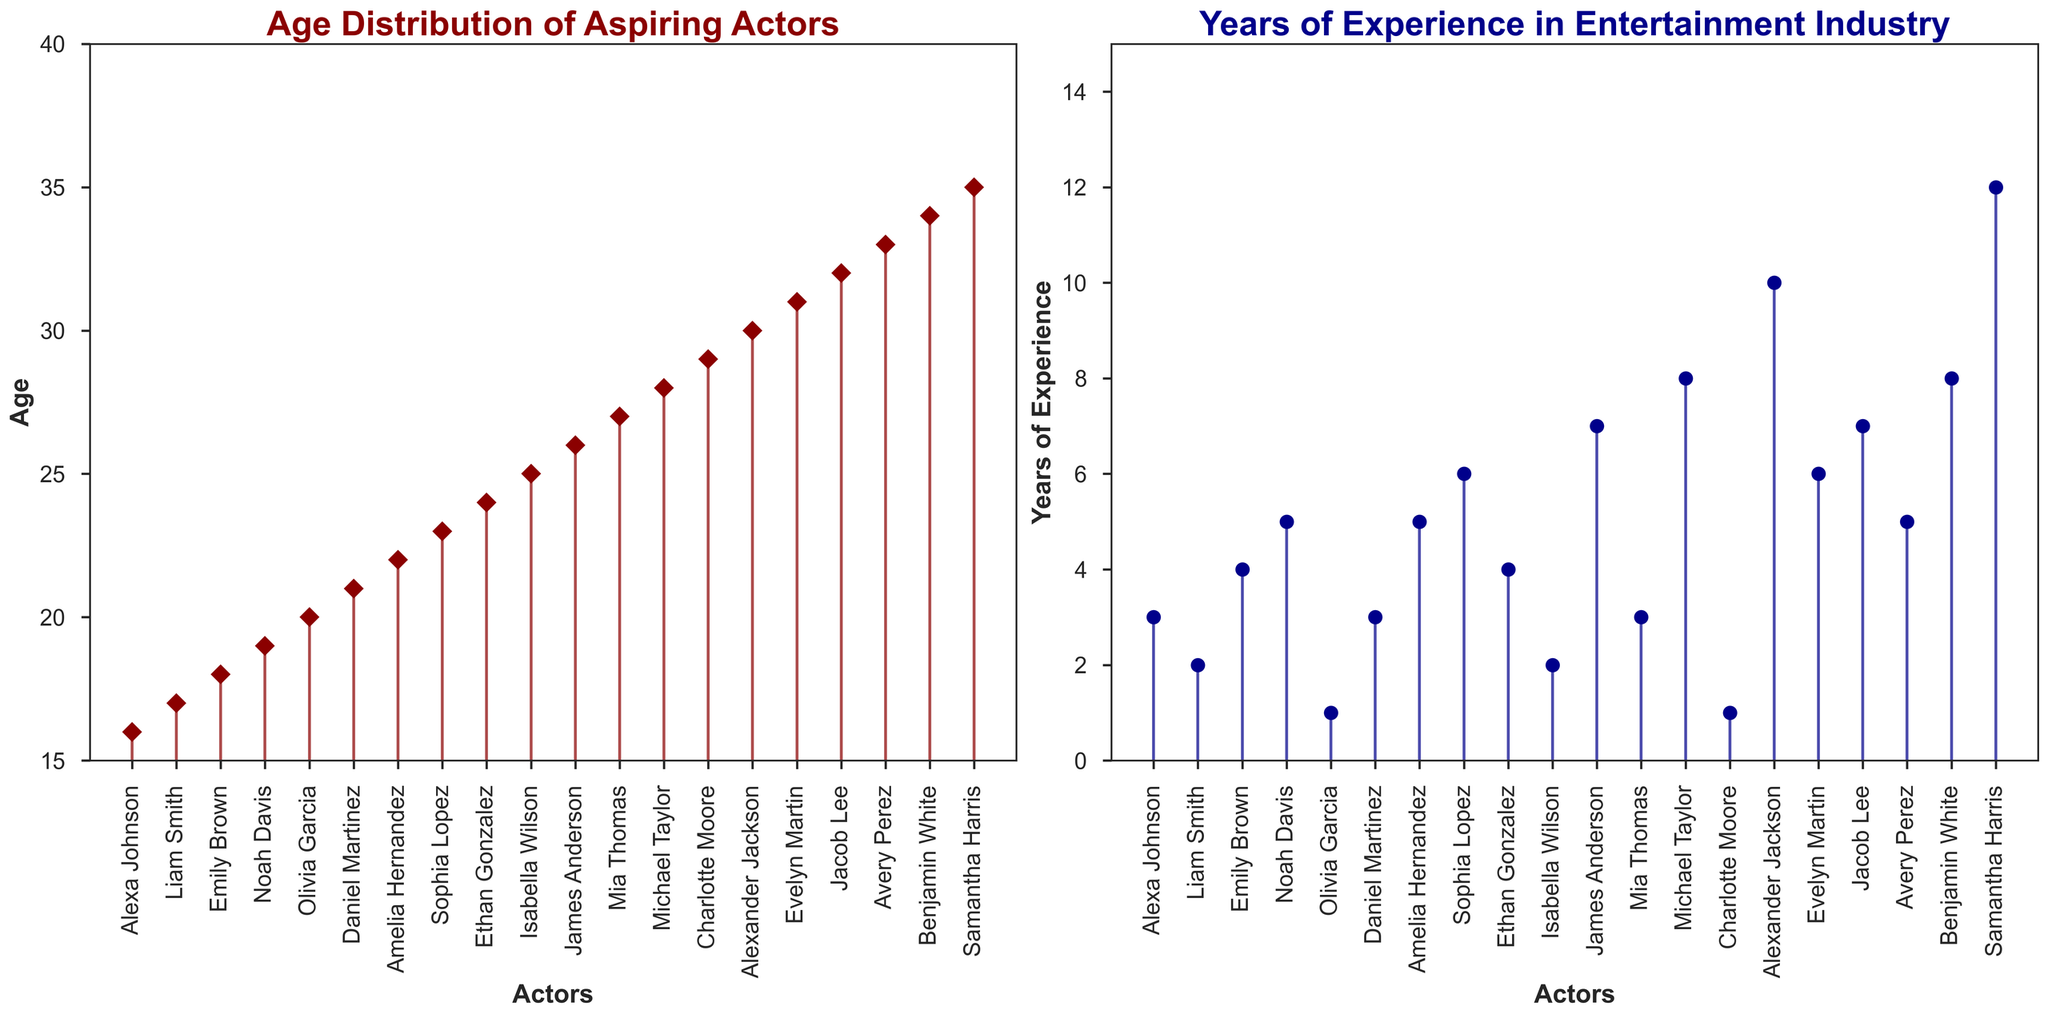Which axis shows the names of the actors in both subplots? The x-axis in both subplots lists the names of the actors. In the figure, the bottom axis shows each actor's name which is rotated 90 degrees for better readability.
Answer: x-axis What are the colors of the stem lines in each subplot? In the age distribution subplot on the left, the stem lines are dark red. In the years of experience subplot on the right, the stem lines are dark blue.
Answer: dark red, dark blue How many actors have their age listed in the age distribution subplot? By counting the names on the x-axis in the age distribution subplot, we can determine there are 20 actors.
Answer: 20 What is the range of ages represented in the age distribution subplot? The y-axis of the age distribution subplot shows the age range from 15 to 40. By examining the data points, the minimum age is 16 and the maximum age is 35.
Answer: 16, 35 Which actor has the highest number of years of experience? From the years of experience subplot, Samantha Harris, shown near the end of the x-axis, has the highest stem, indicating 12 years of experience.
Answer: Samantha Harris What is the average age of the aspiring actors? To find the average age, we sum all the ages and divide by the number of actors. The ages are 16, 17, 18, 19, 20, 21, 22, 23, 24, 25, 26, 27, 28, 29, 30, 31, 32, 33, 34, 35. The sum is 490. There are 20 actors, so the average age is 490 / 20.
Answer: 24.5 Are there any actors with the same age but different years of experience? By analyzing both subplots, it's clear that no two actors have the same age but different years of experience. Each age has a unique corresponding number of years of experience.
Answer: No Which actor is 30 years old and how many years of experience do they have? Based on the age distribution subplot, Alexander Jackson is 30 years old. Referring to the years of experience subplot, Alexander Jackson has 10 years of experience.
Answer: Alexander Jackson, 10 Who is the youngest actor and how many years of experience do they have? Alexa Johnson is the youngest actor, as indicated in the age distribution subplot. The years of experience subplot shows she has 3 years of experience.
Answer: Alexa Johnson, 3 Comparing actors aged 25 and 29, who has more years of experience? Isabella Wilson is 25 years old with 2 years of experience, and Charlotte Moore is 29 years old with 1 year of experience. Hence, Isabella Wilson has more years of experience.
Answer: Isabella Wilson 